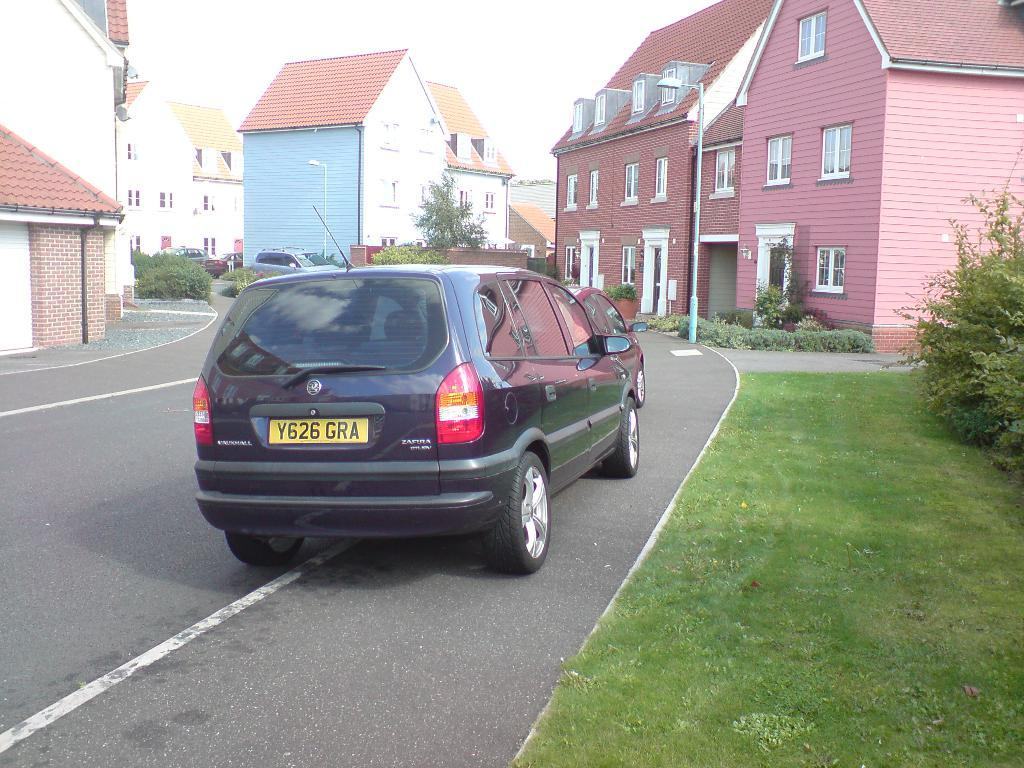<image>
Give a short and clear explanation of the subsequent image. the letters GRA are on the license plate 